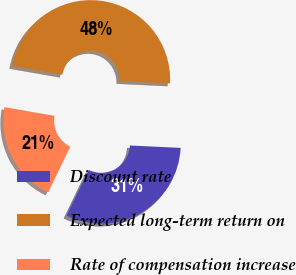Convert chart. <chart><loc_0><loc_0><loc_500><loc_500><pie_chart><fcel>Discount rate<fcel>Expected long-term return on<fcel>Rate of compensation increase<nl><fcel>31.41%<fcel>48.0%<fcel>20.59%<nl></chart> 